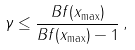Convert formula to latex. <formula><loc_0><loc_0><loc_500><loc_500>\gamma \leq \frac { B f ( x _ { \max } ) } { B f ( x _ { \max } ) - 1 } \, ,</formula> 